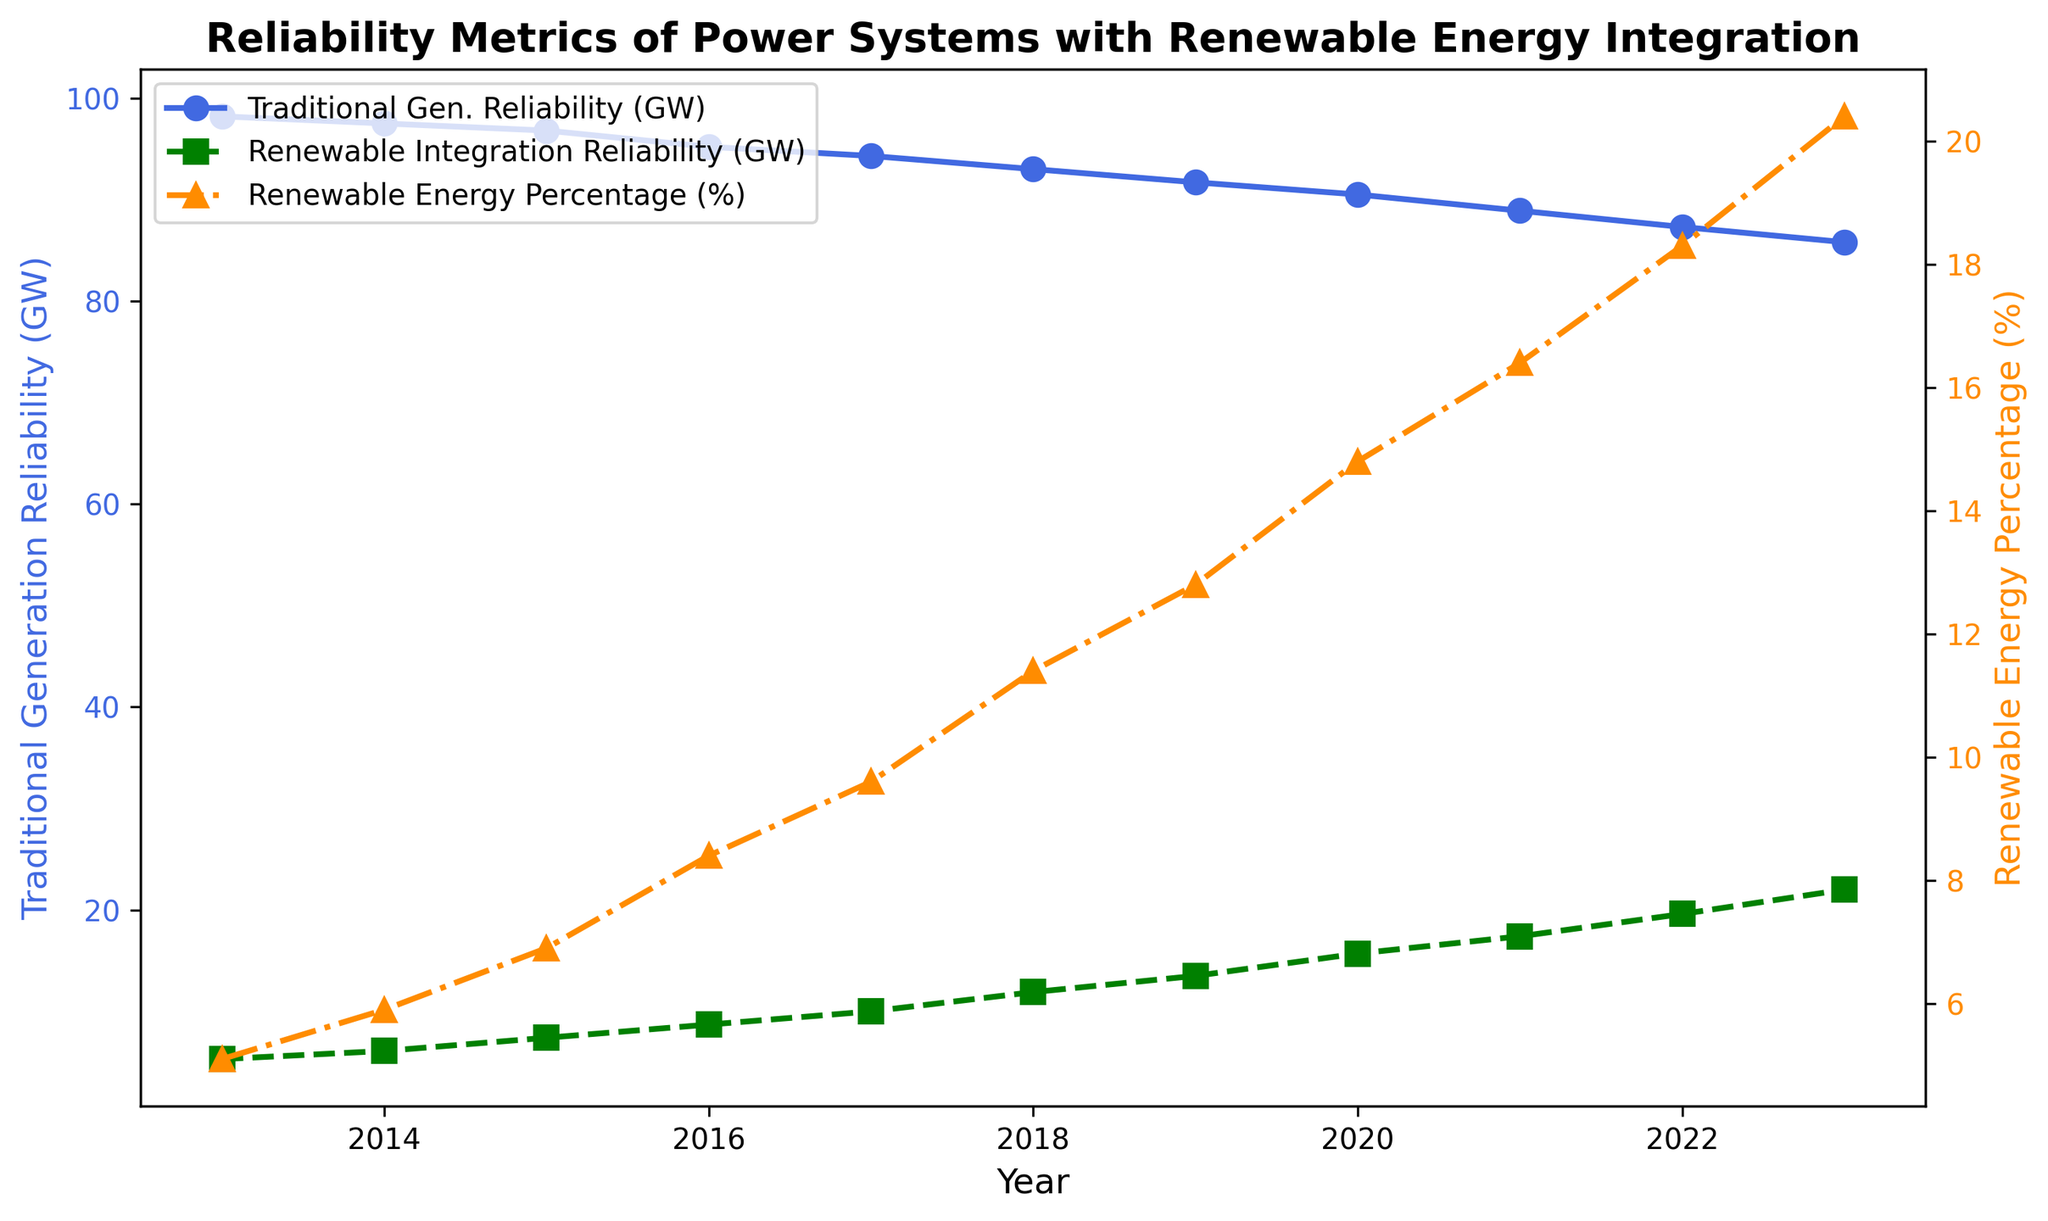What is the difference in Traditional Generation Reliability between 2013 and 2023? From the graph, the Traditional Generation Reliability in 2013 is 98.2 GW and in 2023 is 85.8 GW. The difference is calculated as 98.2 - 85.8.
Answer: 12.4 GW Which year shows the highest Renewable Energy Percentage? The line representing Renewable Energy Percentage reaches its peak in 2023 at 20.4%.
Answer: 2023 Compare the Renewable Integration Reliability in 2015 and 2019. Which year has a higher value? The Renewable Integration Reliability in 2015 is 7.4 GW and in 2019 it is 13.5 GW. Therefore, 2019 has a higher value.
Answer: 2019 By how much did Renewable Integration Reliability increase from 2014 to 2020? In 2014, the Renewable Integration Reliability is 6.1 GW and in 2020 it is 15.7 GW. The increase is calculated as 15.7 - 6.1.
Answer: 9.6 GW What is the average Traditional Generation Reliability over the years 2018 to 2022? To find the average, sum the values from 2018 to 2022 (93.0 + 91.7 + 90.5 + 88.9 + 87.3) and divide by 5. The sum is 451.4, so the average is 451.4 / 5.
Answer: 90.28 GW Identify the year that marks the crossing point where Renewable Integration Reliability exceeds 10 GW. By inspecting the graph, the Renewable Integration Reliability exceeds 10 GW in the year 2017.
Answer: 2017 Which colored line indicates the Renewable Energy Percentage, and how does it trend over the years? The dark orange line represents the Renewable Energy Percentage, and it shows an increasing trend from 2013 to 2023.
Answer: Dark orange, increasing How much did Traditional Generation Reliability decrease from 2013 to 2021? Calculate the difference between the values in 2013 and 2021: 98.2 - 88.9.
Answer: 9.3 GW What is the visual attribute used to differentiate between Traditional Generation Reliability and Renewable Integration Reliability on the same axis? Different colored lines and different line styles are used: solid royal blue for Traditional Generation Reliability and dashed green for Renewable Integration Reliability.
Answer: Color and line style In which year did Renewable Energy Percentage experience the largest single-year jump? By comparing year-on-year changes, the largest increase occurred between 2019 (12.8%) and 2020 (14.8%), a jump of 2.0%.
Answer: 2020 